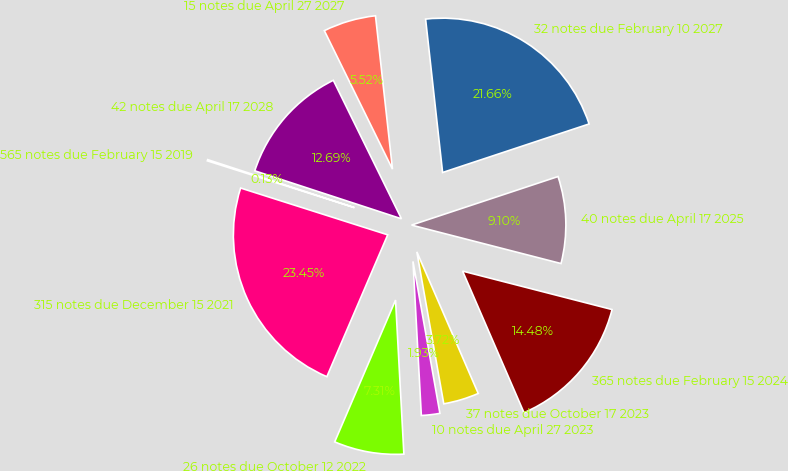Convert chart. <chart><loc_0><loc_0><loc_500><loc_500><pie_chart><fcel>565 notes due February 15 2019<fcel>315 notes due December 15 2021<fcel>26 notes due October 12 2022<fcel>10 notes due April 27 2023<fcel>37 notes due October 17 2023<fcel>365 notes due February 15 2024<fcel>40 notes due April 17 2025<fcel>32 notes due February 10 2027<fcel>15 notes due April 27 2027<fcel>42 notes due April 17 2028<nl><fcel>0.13%<fcel>23.45%<fcel>7.31%<fcel>1.93%<fcel>3.72%<fcel>14.48%<fcel>9.1%<fcel>21.66%<fcel>5.52%<fcel>12.69%<nl></chart> 